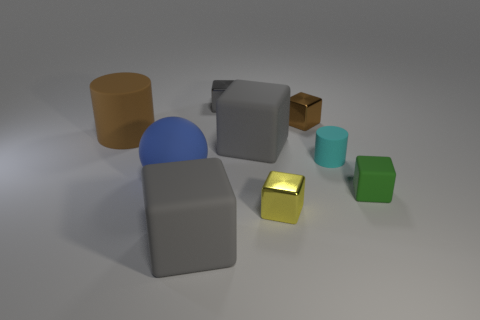What material is the tiny thing that is the same color as the big matte cylinder?
Provide a succinct answer. Metal. There is a cube that is the same color as the large rubber cylinder; what size is it?
Make the answer very short. Small. Is there a red block of the same size as the green matte cube?
Offer a very short reply. No. Is the material of the gray block in front of the tiny yellow metal thing the same as the green thing?
Your answer should be compact. Yes. Are there the same number of large blocks that are behind the small gray cube and cyan cylinders that are on the left side of the blue thing?
Provide a short and direct response. Yes. The object that is both on the right side of the small yellow object and in front of the large sphere has what shape?
Your response must be concise. Cube. What number of small gray metallic things are right of the yellow metallic object?
Ensure brevity in your answer.  0. What number of other objects are there of the same shape as the small brown object?
Offer a terse response. 5. Is the number of rubber cubes less than the number of large green metallic things?
Your answer should be very brief. No. There is a object that is both to the left of the yellow block and behind the big cylinder; how big is it?
Give a very brief answer. Small. 